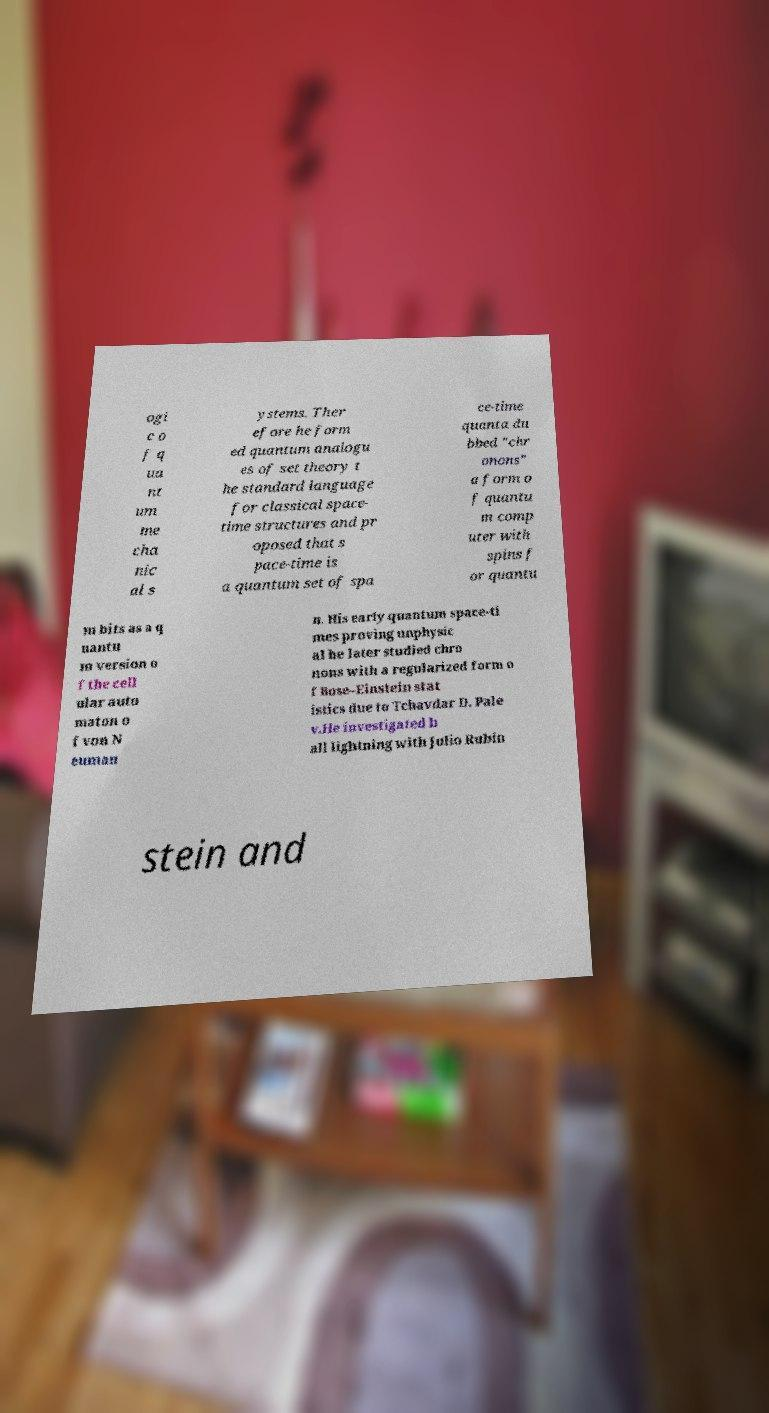I need the written content from this picture converted into text. Can you do that? ogi c o f q ua nt um me cha nic al s ystems. Ther efore he form ed quantum analogu es of set theory t he standard language for classical space- time structures and pr oposed that s pace-time is a quantum set of spa ce-time quanta du bbed "chr onons" a form o f quantu m comp uter with spins f or quantu m bits as a q uantu m version o f the cell ular auto maton o f von N euman n. His early quantum space-ti mes proving unphysic al he later studied chro nons with a regularized form o f Bose–Einstein stat istics due to Tchavdar D. Pale v.He investigated b all lightning with Julio Rubin stein and 